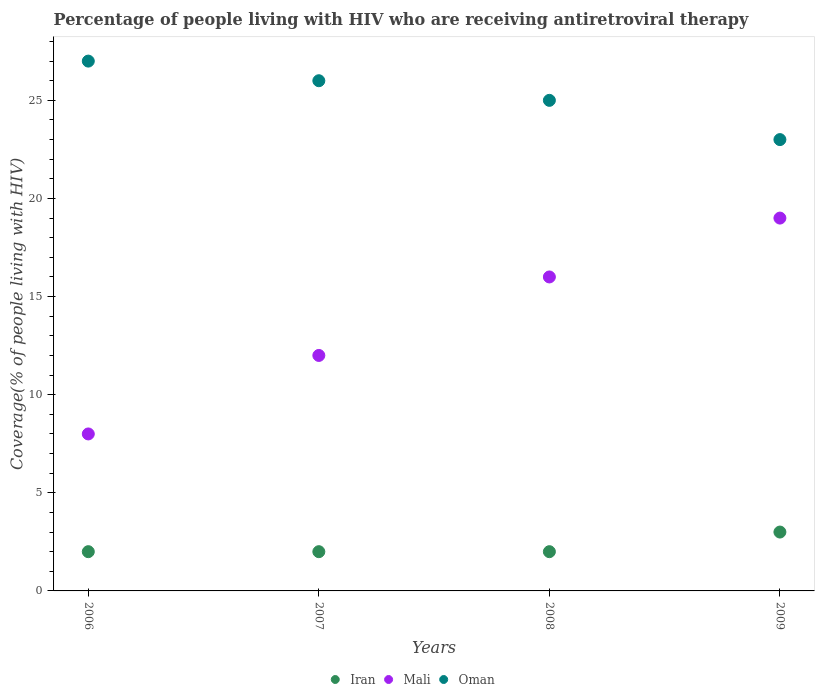What is the percentage of the HIV infected people who are receiving antiretroviral therapy in Oman in 2006?
Offer a terse response. 27. Across all years, what is the maximum percentage of the HIV infected people who are receiving antiretroviral therapy in Mali?
Ensure brevity in your answer.  19. Across all years, what is the minimum percentage of the HIV infected people who are receiving antiretroviral therapy in Oman?
Offer a very short reply. 23. In which year was the percentage of the HIV infected people who are receiving antiretroviral therapy in Mali maximum?
Offer a very short reply. 2009. In which year was the percentage of the HIV infected people who are receiving antiretroviral therapy in Iran minimum?
Ensure brevity in your answer.  2006. What is the total percentage of the HIV infected people who are receiving antiretroviral therapy in Oman in the graph?
Your response must be concise. 101. What is the difference between the percentage of the HIV infected people who are receiving antiretroviral therapy in Mali in 2007 and that in 2008?
Ensure brevity in your answer.  -4. What is the difference between the percentage of the HIV infected people who are receiving antiretroviral therapy in Mali in 2008 and the percentage of the HIV infected people who are receiving antiretroviral therapy in Oman in 2009?
Your answer should be very brief. -7. What is the average percentage of the HIV infected people who are receiving antiretroviral therapy in Mali per year?
Your answer should be compact. 13.75. In the year 2009, what is the difference between the percentage of the HIV infected people who are receiving antiretroviral therapy in Oman and percentage of the HIV infected people who are receiving antiretroviral therapy in Iran?
Provide a short and direct response. 20. In how many years, is the percentage of the HIV infected people who are receiving antiretroviral therapy in Mali greater than 16 %?
Provide a short and direct response. 1. What is the ratio of the percentage of the HIV infected people who are receiving antiretroviral therapy in Mali in 2008 to that in 2009?
Keep it short and to the point. 0.84. What is the difference between the highest and the second highest percentage of the HIV infected people who are receiving antiretroviral therapy in Mali?
Make the answer very short. 3. What is the difference between the highest and the lowest percentage of the HIV infected people who are receiving antiretroviral therapy in Iran?
Give a very brief answer. 1. In how many years, is the percentage of the HIV infected people who are receiving antiretroviral therapy in Iran greater than the average percentage of the HIV infected people who are receiving antiretroviral therapy in Iran taken over all years?
Your answer should be very brief. 1. Is the sum of the percentage of the HIV infected people who are receiving antiretroviral therapy in Iran in 2006 and 2008 greater than the maximum percentage of the HIV infected people who are receiving antiretroviral therapy in Oman across all years?
Provide a short and direct response. No. Is the percentage of the HIV infected people who are receiving antiretroviral therapy in Mali strictly greater than the percentage of the HIV infected people who are receiving antiretroviral therapy in Iran over the years?
Your response must be concise. Yes. Is the percentage of the HIV infected people who are receiving antiretroviral therapy in Mali strictly less than the percentage of the HIV infected people who are receiving antiretroviral therapy in Iran over the years?
Your answer should be very brief. No. What is the difference between two consecutive major ticks on the Y-axis?
Give a very brief answer. 5. Does the graph contain any zero values?
Offer a terse response. No. Does the graph contain grids?
Give a very brief answer. No. Where does the legend appear in the graph?
Provide a short and direct response. Bottom center. What is the title of the graph?
Provide a succinct answer. Percentage of people living with HIV who are receiving antiretroviral therapy. What is the label or title of the X-axis?
Your answer should be very brief. Years. What is the label or title of the Y-axis?
Offer a very short reply. Coverage(% of people living with HIV). What is the Coverage(% of people living with HIV) in Oman in 2006?
Your answer should be compact. 27. What is the Coverage(% of people living with HIV) of Iran in 2007?
Provide a short and direct response. 2. What is the Coverage(% of people living with HIV) in Mali in 2007?
Ensure brevity in your answer.  12. What is the Coverage(% of people living with HIV) in Iran in 2008?
Offer a terse response. 2. What is the Coverage(% of people living with HIV) of Mali in 2008?
Ensure brevity in your answer.  16. What is the Coverage(% of people living with HIV) of Iran in 2009?
Your answer should be very brief. 3. Across all years, what is the maximum Coverage(% of people living with HIV) in Mali?
Provide a succinct answer. 19. Across all years, what is the minimum Coverage(% of people living with HIV) in Oman?
Offer a very short reply. 23. What is the total Coverage(% of people living with HIV) of Iran in the graph?
Provide a succinct answer. 9. What is the total Coverage(% of people living with HIV) in Oman in the graph?
Make the answer very short. 101. What is the difference between the Coverage(% of people living with HIV) of Oman in 2006 and that in 2007?
Ensure brevity in your answer.  1. What is the difference between the Coverage(% of people living with HIV) in Iran in 2006 and that in 2008?
Your answer should be compact. 0. What is the difference between the Coverage(% of people living with HIV) of Mali in 2006 and that in 2008?
Provide a succinct answer. -8. What is the difference between the Coverage(% of people living with HIV) in Oman in 2006 and that in 2008?
Offer a terse response. 2. What is the difference between the Coverage(% of people living with HIV) of Iran in 2007 and that in 2008?
Keep it short and to the point. 0. What is the difference between the Coverage(% of people living with HIV) of Oman in 2007 and that in 2008?
Ensure brevity in your answer.  1. What is the difference between the Coverage(% of people living with HIV) of Iran in 2007 and that in 2009?
Offer a very short reply. -1. What is the difference between the Coverage(% of people living with HIV) in Mali in 2007 and that in 2009?
Give a very brief answer. -7. What is the difference between the Coverage(% of people living with HIV) in Oman in 2008 and that in 2009?
Provide a short and direct response. 2. What is the difference between the Coverage(% of people living with HIV) of Iran in 2006 and the Coverage(% of people living with HIV) of Mali in 2007?
Provide a succinct answer. -10. What is the difference between the Coverage(% of people living with HIV) in Iran in 2006 and the Coverage(% of people living with HIV) in Oman in 2007?
Your response must be concise. -24. What is the difference between the Coverage(% of people living with HIV) of Iran in 2006 and the Coverage(% of people living with HIV) of Oman in 2008?
Provide a short and direct response. -23. What is the difference between the Coverage(% of people living with HIV) in Mali in 2006 and the Coverage(% of people living with HIV) in Oman in 2008?
Keep it short and to the point. -17. What is the difference between the Coverage(% of people living with HIV) in Iran in 2006 and the Coverage(% of people living with HIV) in Mali in 2009?
Keep it short and to the point. -17. What is the difference between the Coverage(% of people living with HIV) in Mali in 2006 and the Coverage(% of people living with HIV) in Oman in 2009?
Give a very brief answer. -15. What is the difference between the Coverage(% of people living with HIV) of Mali in 2007 and the Coverage(% of people living with HIV) of Oman in 2008?
Your answer should be compact. -13. What is the difference between the Coverage(% of people living with HIV) of Mali in 2007 and the Coverage(% of people living with HIV) of Oman in 2009?
Keep it short and to the point. -11. What is the average Coverage(% of people living with HIV) of Iran per year?
Your response must be concise. 2.25. What is the average Coverage(% of people living with HIV) in Mali per year?
Provide a short and direct response. 13.75. What is the average Coverage(% of people living with HIV) in Oman per year?
Ensure brevity in your answer.  25.25. In the year 2006, what is the difference between the Coverage(% of people living with HIV) of Iran and Coverage(% of people living with HIV) of Mali?
Give a very brief answer. -6. In the year 2007, what is the difference between the Coverage(% of people living with HIV) of Iran and Coverage(% of people living with HIV) of Mali?
Provide a short and direct response. -10. In the year 2007, what is the difference between the Coverage(% of people living with HIV) of Iran and Coverage(% of people living with HIV) of Oman?
Provide a short and direct response. -24. In the year 2008, what is the difference between the Coverage(% of people living with HIV) in Iran and Coverage(% of people living with HIV) in Mali?
Make the answer very short. -14. In the year 2008, what is the difference between the Coverage(% of people living with HIV) in Mali and Coverage(% of people living with HIV) in Oman?
Ensure brevity in your answer.  -9. In the year 2009, what is the difference between the Coverage(% of people living with HIV) in Iran and Coverage(% of people living with HIV) in Oman?
Make the answer very short. -20. In the year 2009, what is the difference between the Coverage(% of people living with HIV) of Mali and Coverage(% of people living with HIV) of Oman?
Give a very brief answer. -4. What is the ratio of the Coverage(% of people living with HIV) in Mali in 2006 to that in 2007?
Provide a short and direct response. 0.67. What is the ratio of the Coverage(% of people living with HIV) of Iran in 2006 to that in 2008?
Your answer should be compact. 1. What is the ratio of the Coverage(% of people living with HIV) in Mali in 2006 to that in 2008?
Your answer should be very brief. 0.5. What is the ratio of the Coverage(% of people living with HIV) in Mali in 2006 to that in 2009?
Provide a succinct answer. 0.42. What is the ratio of the Coverage(% of people living with HIV) in Oman in 2006 to that in 2009?
Offer a very short reply. 1.17. What is the ratio of the Coverage(% of people living with HIV) in Iran in 2007 to that in 2008?
Make the answer very short. 1. What is the ratio of the Coverage(% of people living with HIV) of Oman in 2007 to that in 2008?
Make the answer very short. 1.04. What is the ratio of the Coverage(% of people living with HIV) in Mali in 2007 to that in 2009?
Make the answer very short. 0.63. What is the ratio of the Coverage(% of people living with HIV) in Oman in 2007 to that in 2009?
Provide a short and direct response. 1.13. What is the ratio of the Coverage(% of people living with HIV) of Mali in 2008 to that in 2009?
Make the answer very short. 0.84. What is the ratio of the Coverage(% of people living with HIV) of Oman in 2008 to that in 2009?
Make the answer very short. 1.09. What is the difference between the highest and the second highest Coverage(% of people living with HIV) of Iran?
Offer a terse response. 1. What is the difference between the highest and the lowest Coverage(% of people living with HIV) in Mali?
Offer a very short reply. 11. What is the difference between the highest and the lowest Coverage(% of people living with HIV) of Oman?
Offer a terse response. 4. 